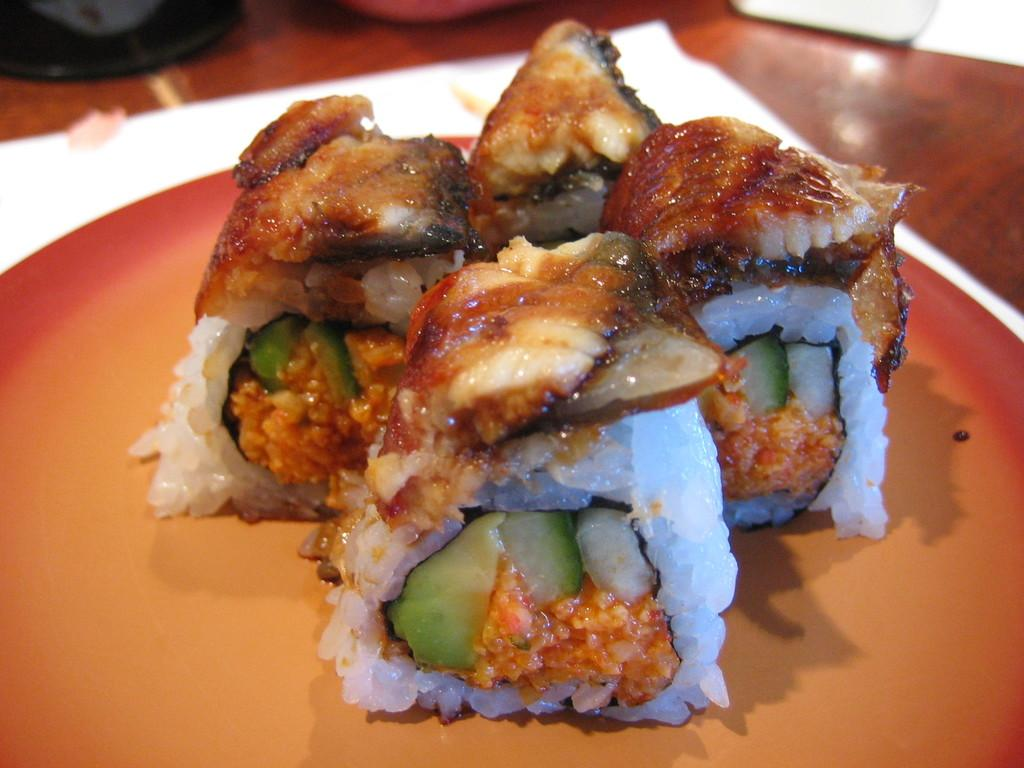What type of furniture is present in the image? There is a table in the image. What is placed on the table? There is a plate on the table. What is on the plate? The plate contains sweets. What type of cave can be seen in the background of the image? There is no cave present in the image; it only features a table with a plate of sweets. 